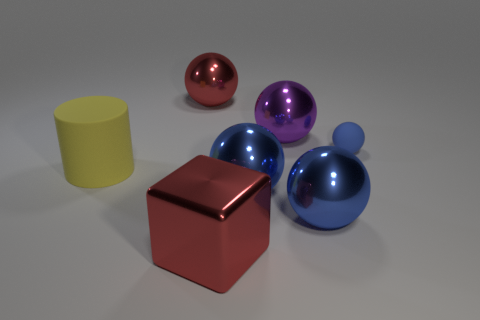What is the shape of the large thing that is both in front of the blue rubber object and on the left side of the big block?
Your response must be concise. Cylinder. Is the number of small things that are left of the yellow rubber thing the same as the number of cylinders in front of the big block?
Keep it short and to the point. Yes. Is there a small brown cylinder made of the same material as the purple ball?
Your answer should be very brief. No. Does the large purple ball that is on the left side of the small blue ball have the same material as the small sphere?
Offer a terse response. No. How big is the object that is on the left side of the large red shiny cube and right of the yellow cylinder?
Your response must be concise. Large. The big rubber thing is what color?
Ensure brevity in your answer.  Yellow. How many large red metallic objects are there?
Ensure brevity in your answer.  2. What number of large balls have the same color as the big matte object?
Make the answer very short. 0. There is a rubber object that is to the left of the small matte ball; is it the same shape as the red shiny thing behind the large yellow rubber thing?
Your response must be concise. No. The metal thing to the left of the big red metal thing that is in front of the big red thing behind the small blue ball is what color?
Your answer should be compact. Red. 